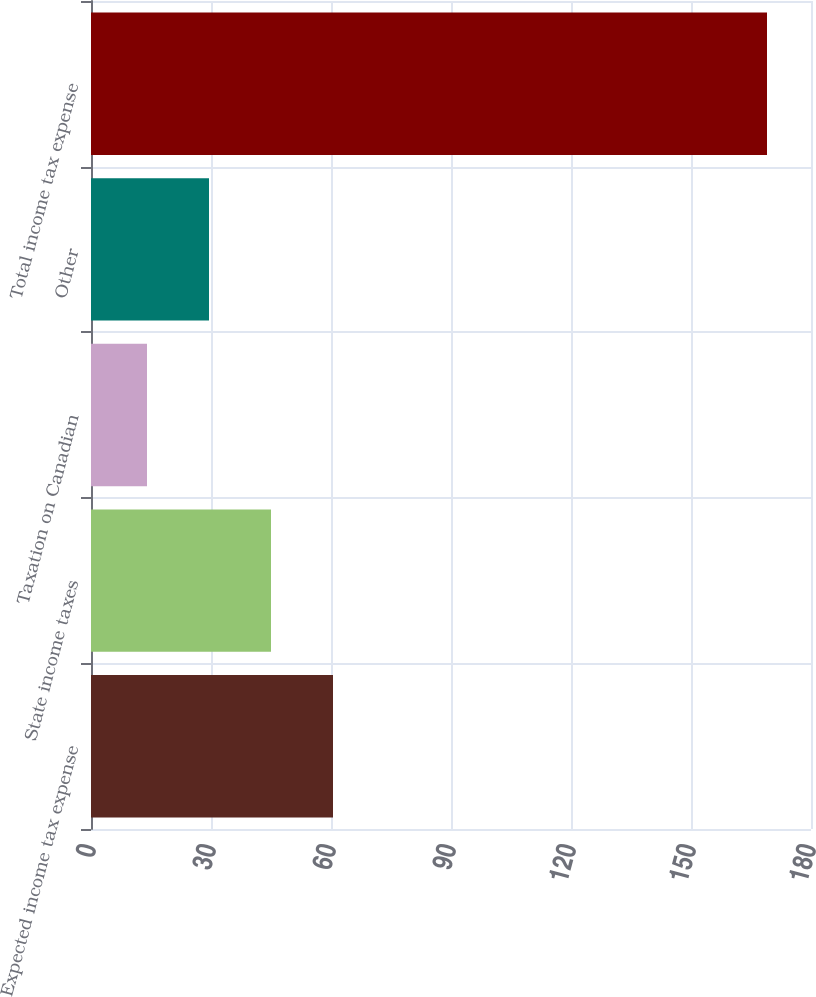Convert chart. <chart><loc_0><loc_0><loc_500><loc_500><bar_chart><fcel>Expected income tax expense<fcel>State income taxes<fcel>Taxation on Canadian<fcel>Other<fcel>Total income tax expense<nl><fcel>60.5<fcel>45<fcel>14<fcel>29.5<fcel>169<nl></chart> 